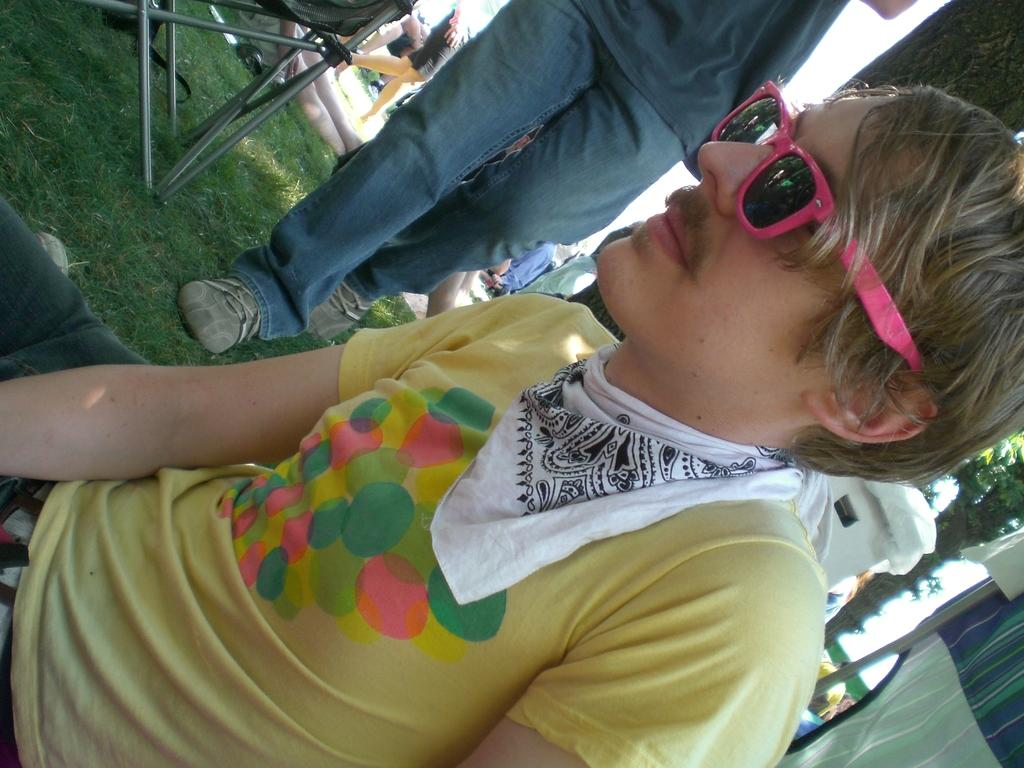What is the man in the image doing? The man is sitting on the grass. What can be seen happening in the background of the image? There are people walking and some people lying on the ground in the background. What type of furniture is visible in the image? There is a chair visible in the image. What type of vegetation is present in the background? Trees are present in the background. What type of material is visible in the image? Cloth is visible in the image. Can you describe any other objects in the image? There are other unspecified objects in the image. How many snakes are crawling on the man in the image? There are no snakes present in the image; the man is sitting on the grass. What type of authority figure is depicted in the image? There is no authority figure depicted in the image; it features a man sitting on the grass and people in the background. 